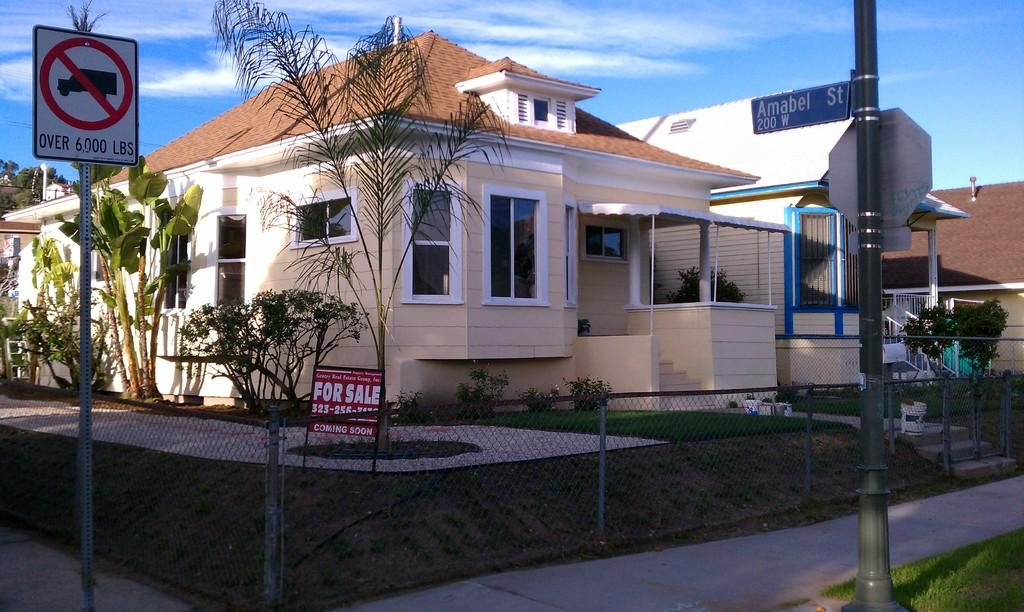What is the color of the house in the image? The house in the image is brown. What type of roof does the house have? The house has roof tiles. What material is used for the windows of the house? The house has window glass. What is present in front of the house to protect it? There is a net grill in the front of the house. What type of vegetation is in front of the house? There are plants in the front of the house. What safety measure is present in front of the house? There is a caution board in the front of the house. What songs can be heard coming from the house in the image? There is no indication in the image that songs are being played or heard from the house. 